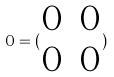<formula> <loc_0><loc_0><loc_500><loc_500>0 = ( \begin{matrix} 0 & 0 \\ 0 & 0 \end{matrix} )</formula> 